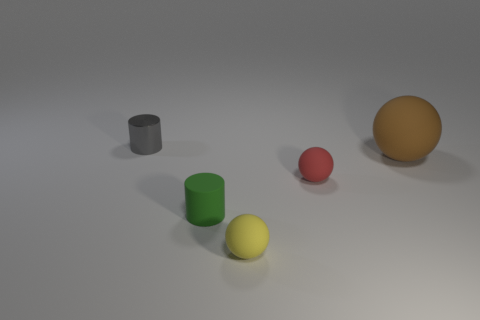Is there any other thing that has the same size as the brown matte ball?
Provide a short and direct response. No. There is a small cylinder right of the gray metallic object; is its color the same as the matte thing on the right side of the tiny red ball?
Offer a very short reply. No. Is there another cylinder that has the same material as the small green cylinder?
Make the answer very short. No. What color is the metal cylinder?
Your answer should be compact. Gray. There is a rubber object that is to the left of the small matte sphere in front of the cylinder in front of the big brown sphere; what size is it?
Your response must be concise. Small. What number of other things are the same shape as the brown matte object?
Ensure brevity in your answer.  2. The object that is right of the gray thing and to the left of the tiny yellow sphere is what color?
Provide a short and direct response. Green. Does the small cylinder that is in front of the small gray cylinder have the same color as the metal cylinder?
Ensure brevity in your answer.  No. What number of spheres are big yellow objects or small red matte objects?
Ensure brevity in your answer.  1. What is the shape of the small thing in front of the green rubber thing?
Your answer should be compact. Sphere. 